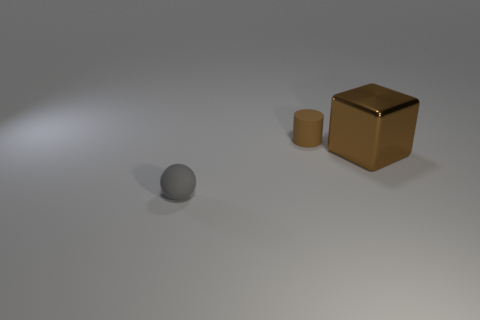How many other things are the same size as the brown shiny object?
Offer a very short reply. 0. Are there more small spheres that are behind the big brown object than things?
Your answer should be very brief. No. Is there any other thing of the same color as the shiny block?
Provide a succinct answer. Yes. What shape is the brown object that is made of the same material as the gray sphere?
Offer a very short reply. Cylinder. Does the brown object that is to the right of the cylinder have the same material as the small ball?
Your response must be concise. No. There is another thing that is the same color as the large shiny thing; what shape is it?
Keep it short and to the point. Cylinder. Does the tiny object that is in front of the brown shiny cube have the same color as the thing behind the large metallic thing?
Your answer should be compact. No. How many things are behind the tiny gray rubber object and in front of the tiny matte cylinder?
Your answer should be very brief. 1. What is the material of the brown cube?
Your response must be concise. Metal. What is the shape of the rubber thing that is the same size as the matte ball?
Your answer should be compact. Cylinder. 